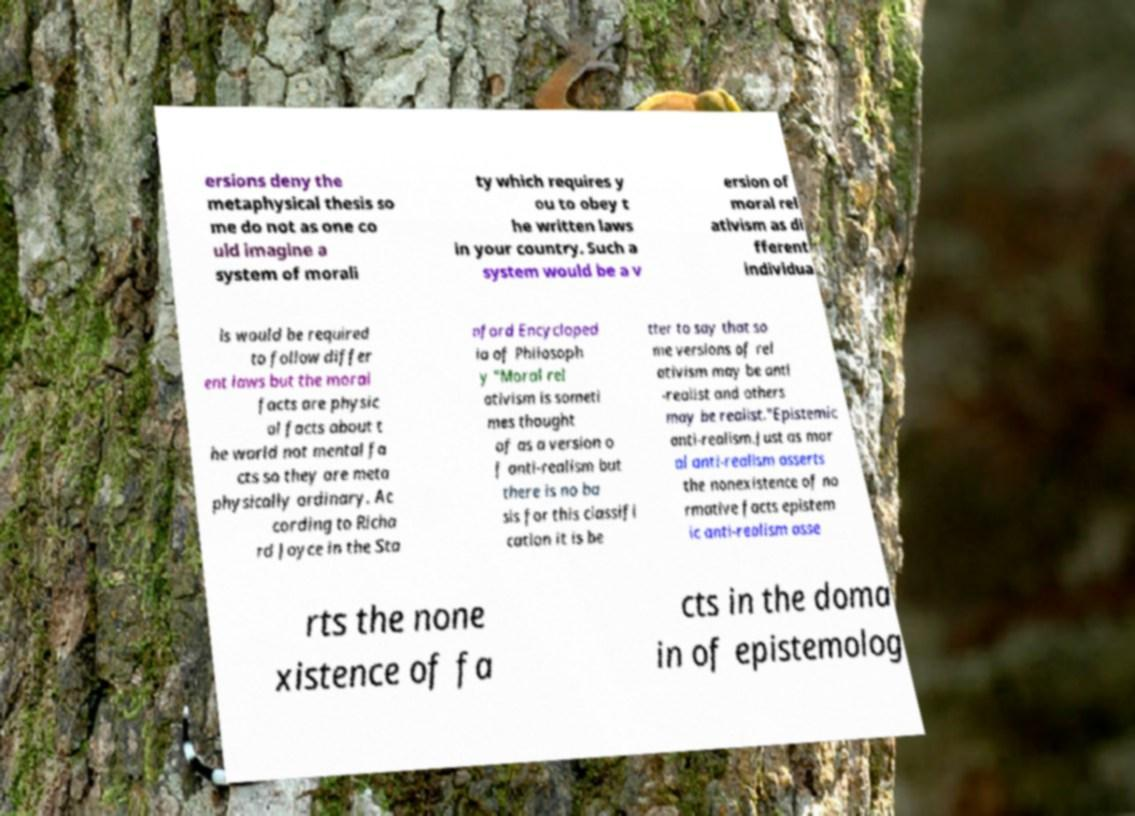I need the written content from this picture converted into text. Can you do that? ersions deny the metaphysical thesis so me do not as one co uld imagine a system of morali ty which requires y ou to obey t he written laws in your country. Such a system would be a v ersion of moral rel ativism as di fferent individua ls would be required to follow differ ent laws but the moral facts are physic al facts about t he world not mental fa cts so they are meta physically ordinary. Ac cording to Richa rd Joyce in the Sta nford Encycloped ia of Philosoph y "Moral rel ativism is someti mes thought of as a version o f anti-realism but there is no ba sis for this classifi cation it is be tter to say that so me versions of rel ativism may be anti -realist and others may be realist."Epistemic anti-realism.Just as mor al anti-realism asserts the nonexistence of no rmative facts epistem ic anti-realism asse rts the none xistence of fa cts in the doma in of epistemolog 